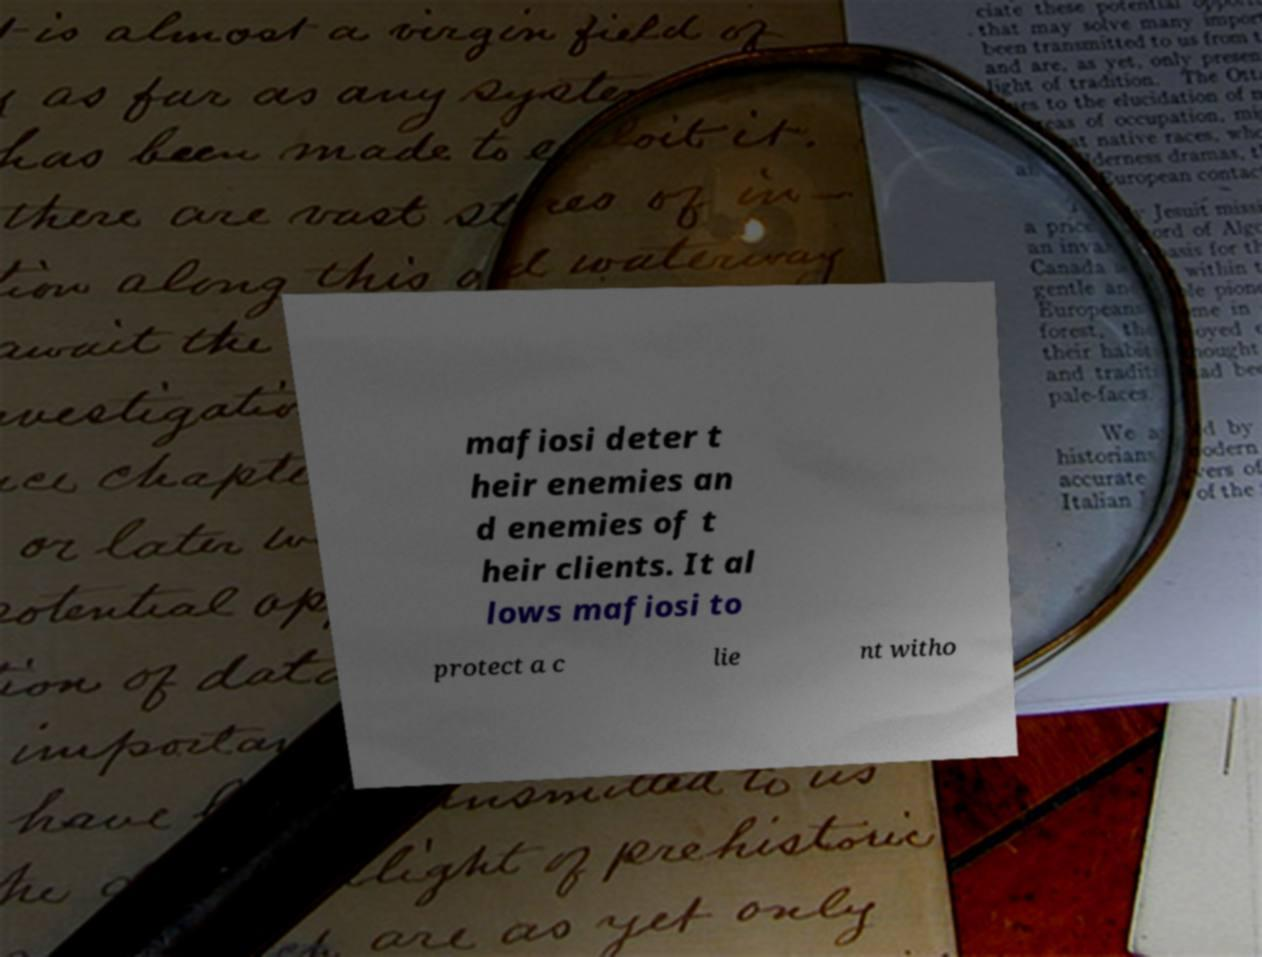Could you assist in decoding the text presented in this image and type it out clearly? mafiosi deter t heir enemies an d enemies of t heir clients. It al lows mafiosi to protect a c lie nt witho 